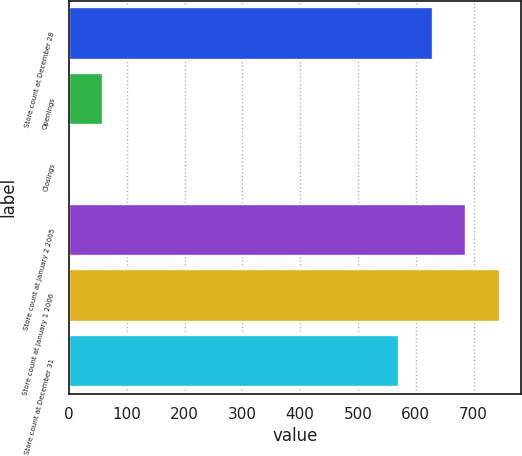Convert chart to OTSL. <chart><loc_0><loc_0><loc_500><loc_500><bar_chart><fcel>Store count at December 28<fcel>Openings<fcel>Closings<fcel>Store count at January 2 2005<fcel>Store count at January 1 2006<fcel>Store count at December 31<nl><fcel>629<fcel>59<fcel>1<fcel>687<fcel>745<fcel>571<nl></chart> 